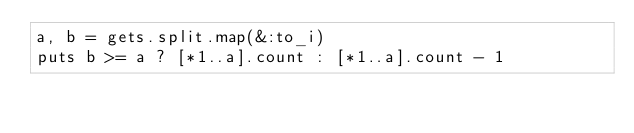<code> <loc_0><loc_0><loc_500><loc_500><_Ruby_>a, b = gets.split.map(&:to_i)
puts b >= a ? [*1..a].count : [*1..a].count - 1
</code> 